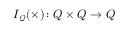<formula> <loc_0><loc_0><loc_500><loc_500>I _ { \mathcal { Q } } ( \times ) \colon Q \times Q \to Q</formula> 